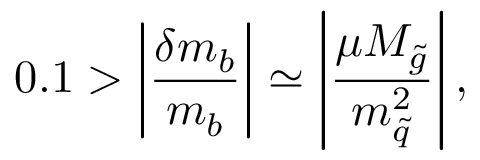<formula> <loc_0><loc_0><loc_500><loc_500>0 . 1 > \left | { \frac { \delta m _ { b } } { m _ { b } } } \right | \simeq \left | { \frac { \mu M _ { \tilde { g } } } { m _ { \tilde { q } } ^ { 2 } } } \right | ,</formula> 